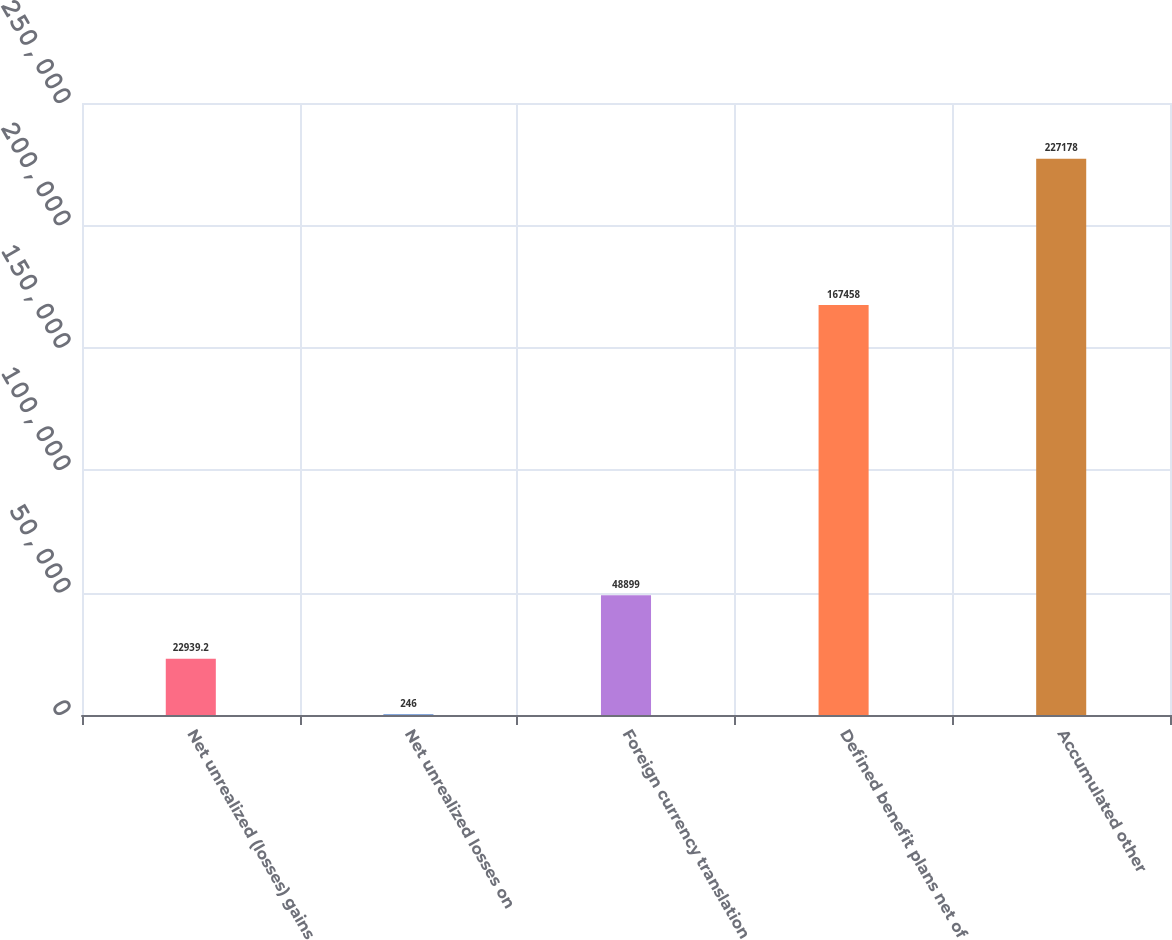Convert chart. <chart><loc_0><loc_0><loc_500><loc_500><bar_chart><fcel>Net unrealized (losses) gains<fcel>Net unrealized losses on<fcel>Foreign currency translation<fcel>Defined benefit plans net of<fcel>Accumulated other<nl><fcel>22939.2<fcel>246<fcel>48899<fcel>167458<fcel>227178<nl></chart> 